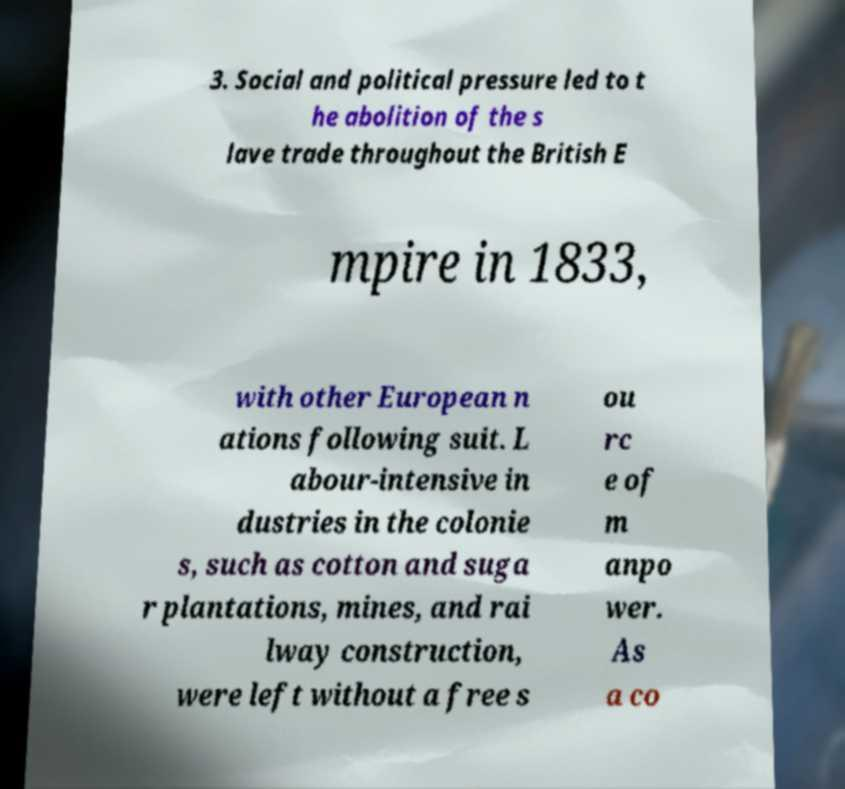Could you extract and type out the text from this image? 3. Social and political pressure led to t he abolition of the s lave trade throughout the British E mpire in 1833, with other European n ations following suit. L abour-intensive in dustries in the colonie s, such as cotton and suga r plantations, mines, and rai lway construction, were left without a free s ou rc e of m anpo wer. As a co 